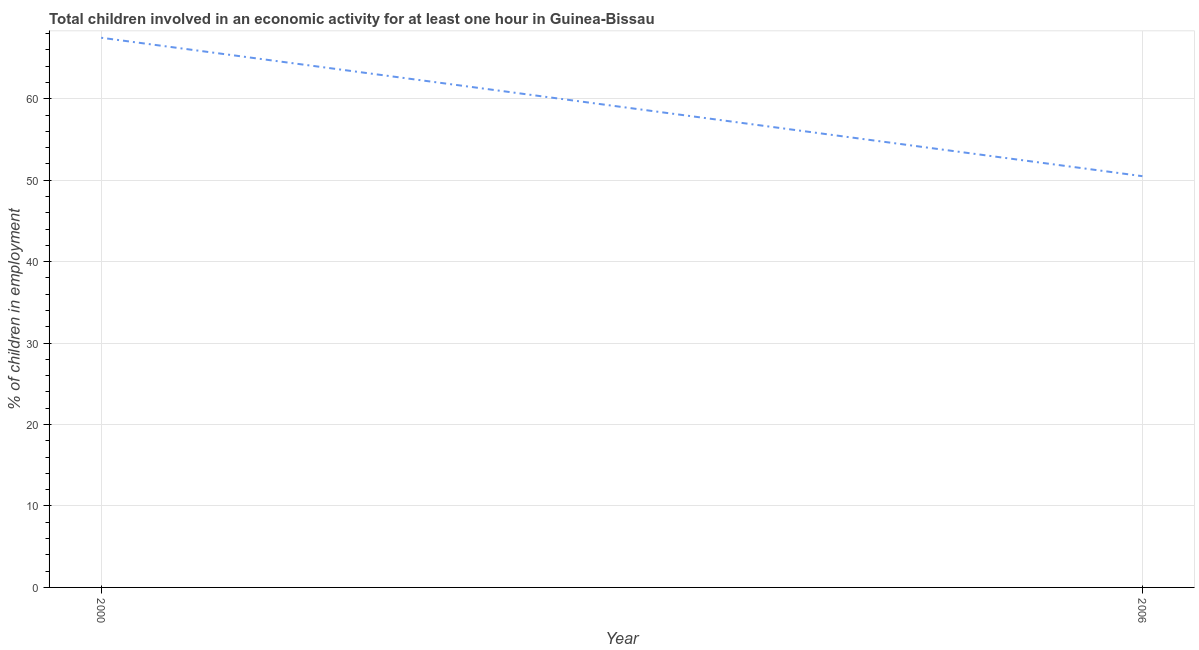What is the percentage of children in employment in 2006?
Make the answer very short. 50.5. Across all years, what is the maximum percentage of children in employment?
Make the answer very short. 67.5. Across all years, what is the minimum percentage of children in employment?
Provide a short and direct response. 50.5. What is the sum of the percentage of children in employment?
Keep it short and to the point. 118. What is the average percentage of children in employment per year?
Make the answer very short. 59. What is the median percentage of children in employment?
Offer a very short reply. 59. In how many years, is the percentage of children in employment greater than 26 %?
Provide a succinct answer. 2. Do a majority of the years between 2006 and 2000 (inclusive) have percentage of children in employment greater than 14 %?
Provide a succinct answer. No. What is the ratio of the percentage of children in employment in 2000 to that in 2006?
Provide a short and direct response. 1.34. Does the percentage of children in employment monotonically increase over the years?
Provide a succinct answer. No. Does the graph contain any zero values?
Your response must be concise. No. What is the title of the graph?
Provide a short and direct response. Total children involved in an economic activity for at least one hour in Guinea-Bissau. What is the label or title of the X-axis?
Give a very brief answer. Year. What is the label or title of the Y-axis?
Provide a succinct answer. % of children in employment. What is the % of children in employment of 2000?
Your answer should be compact. 67.5. What is the % of children in employment of 2006?
Keep it short and to the point. 50.5. What is the difference between the % of children in employment in 2000 and 2006?
Ensure brevity in your answer.  17. What is the ratio of the % of children in employment in 2000 to that in 2006?
Provide a succinct answer. 1.34. 